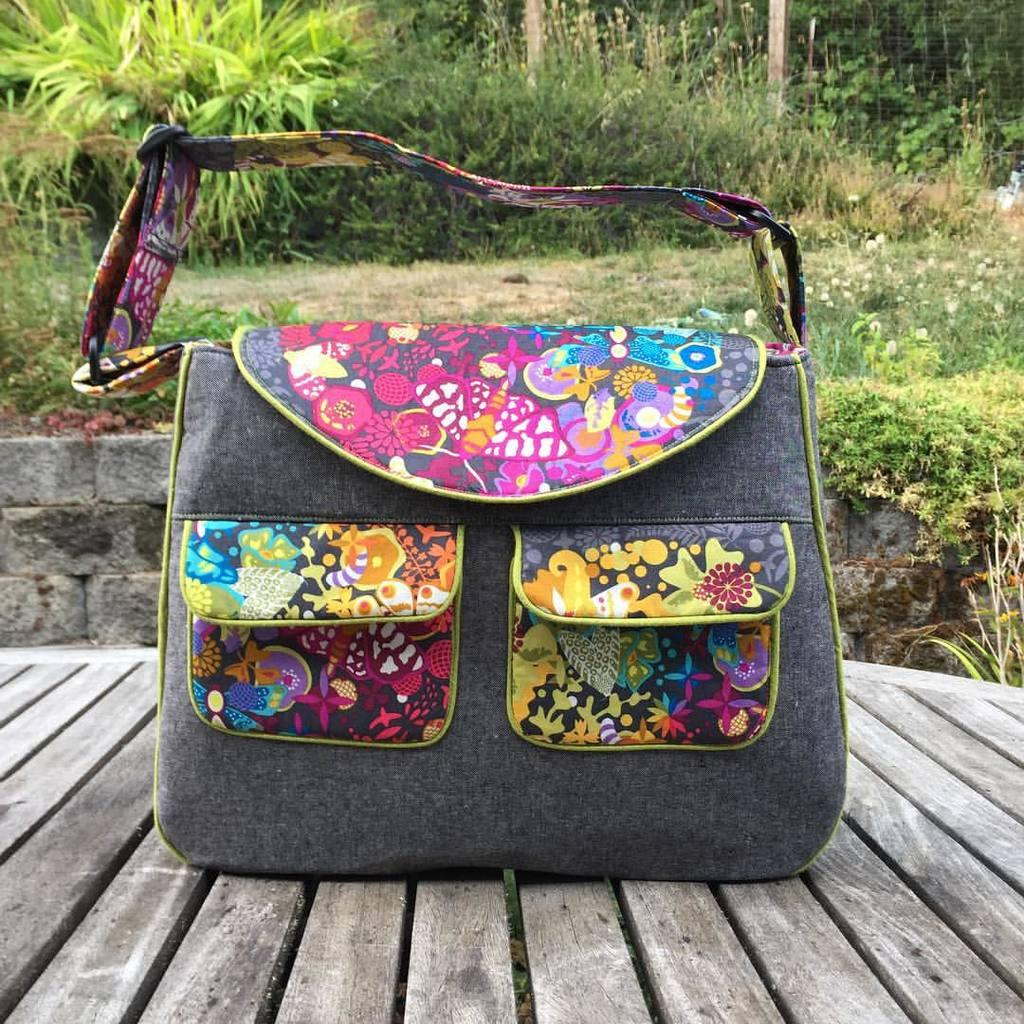What type of accessory is visible in the image? There is a black handbag in the image. Where is the handbag located? The handbag is placed on the floor. What can be seen in the background of the image? There are plants in the background of the image. What type of activity is the flag participating in within the image? There is no flag present in the image, so it cannot be participating in any activity. 